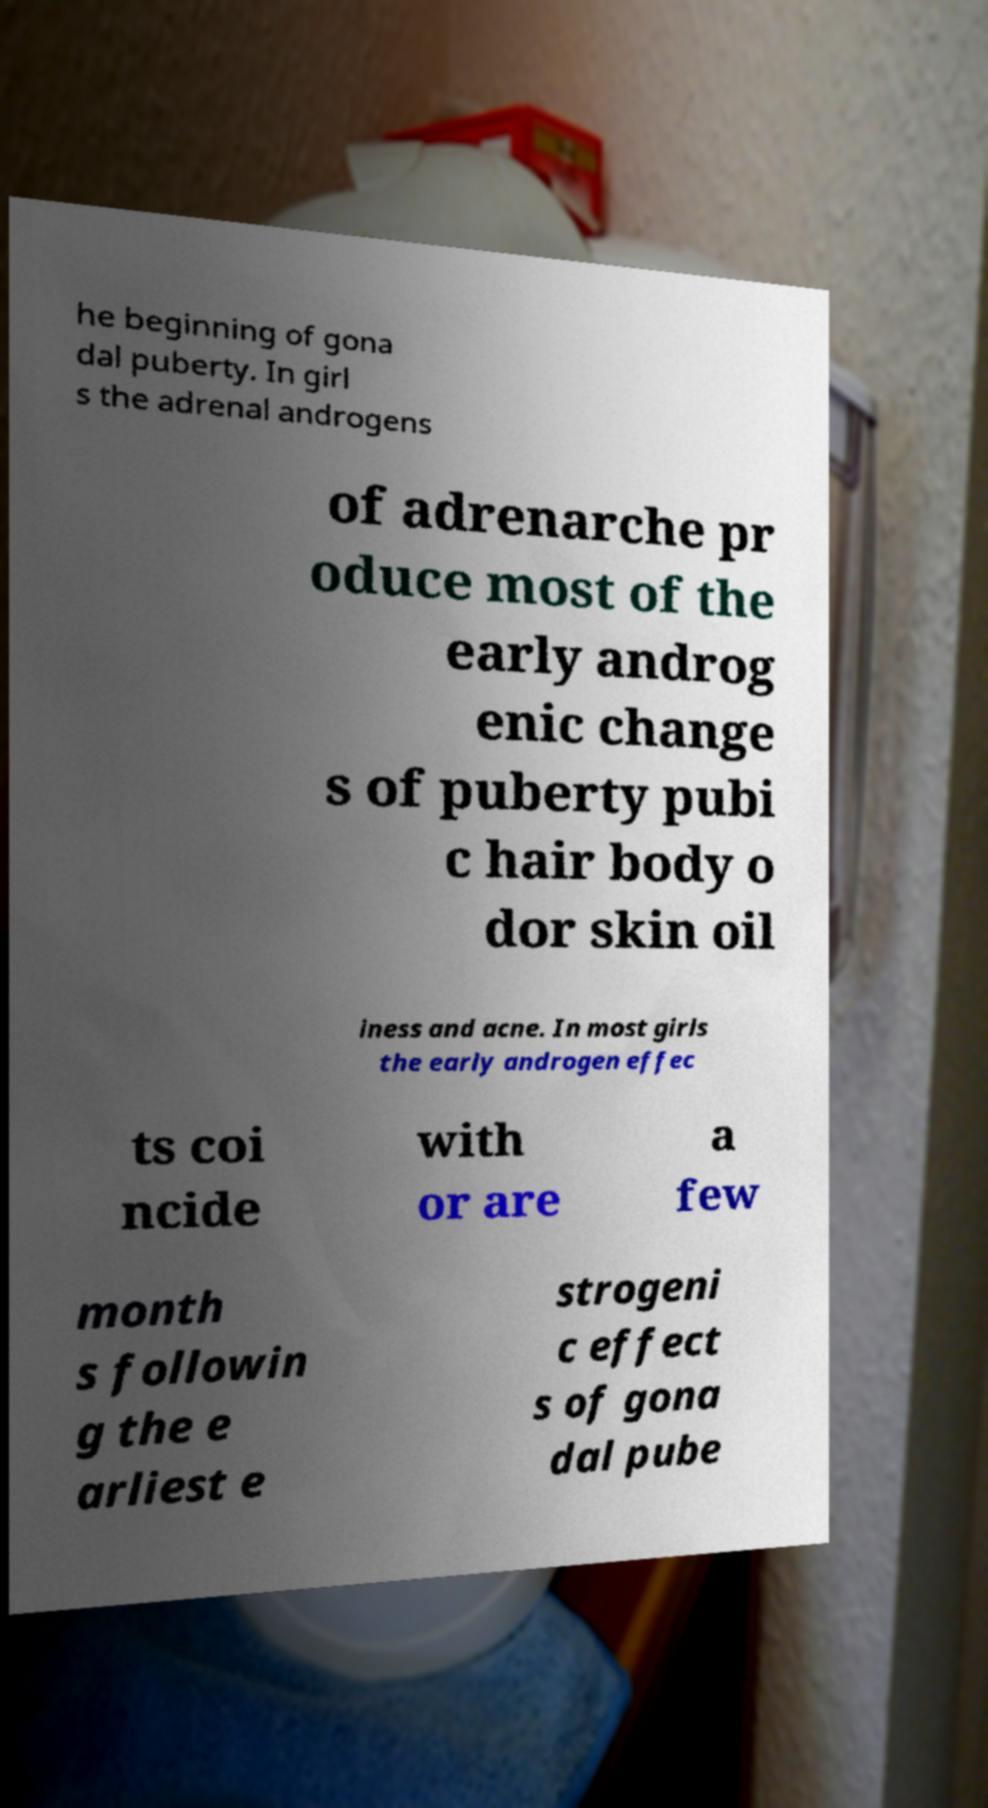There's text embedded in this image that I need extracted. Can you transcribe it verbatim? he beginning of gona dal puberty. In girl s the adrenal androgens of adrenarche pr oduce most of the early androg enic change s of puberty pubi c hair body o dor skin oil iness and acne. In most girls the early androgen effec ts coi ncide with or are a few month s followin g the e arliest e strogeni c effect s of gona dal pube 